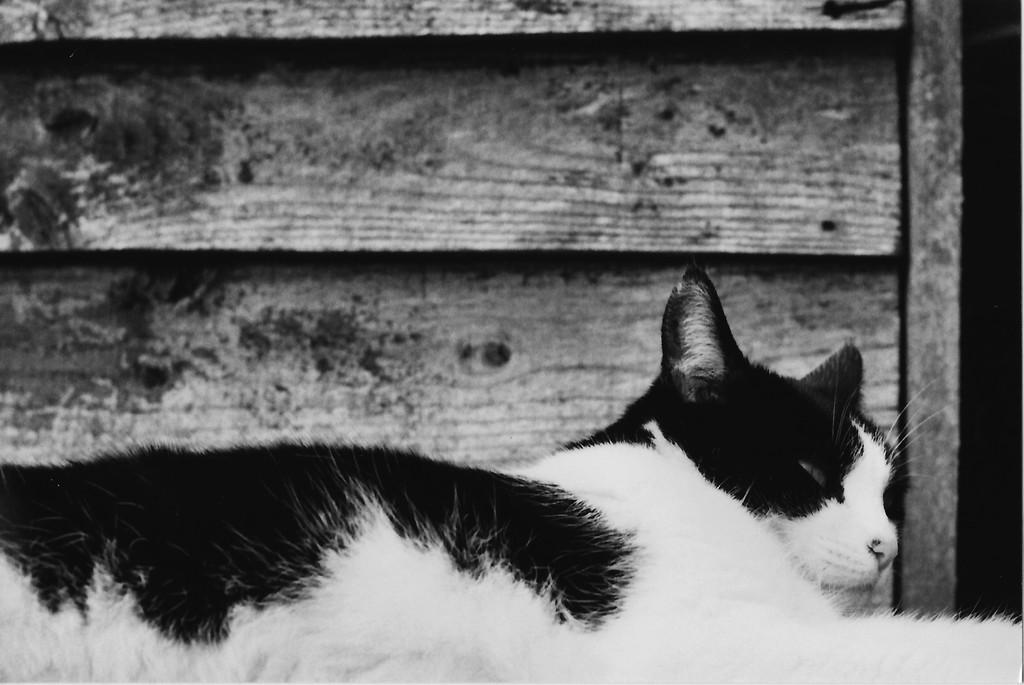How would you summarize this image in a sentence or two? In this picture there is a cat at the bottom side of the image and there is a wooden wall behind it. 